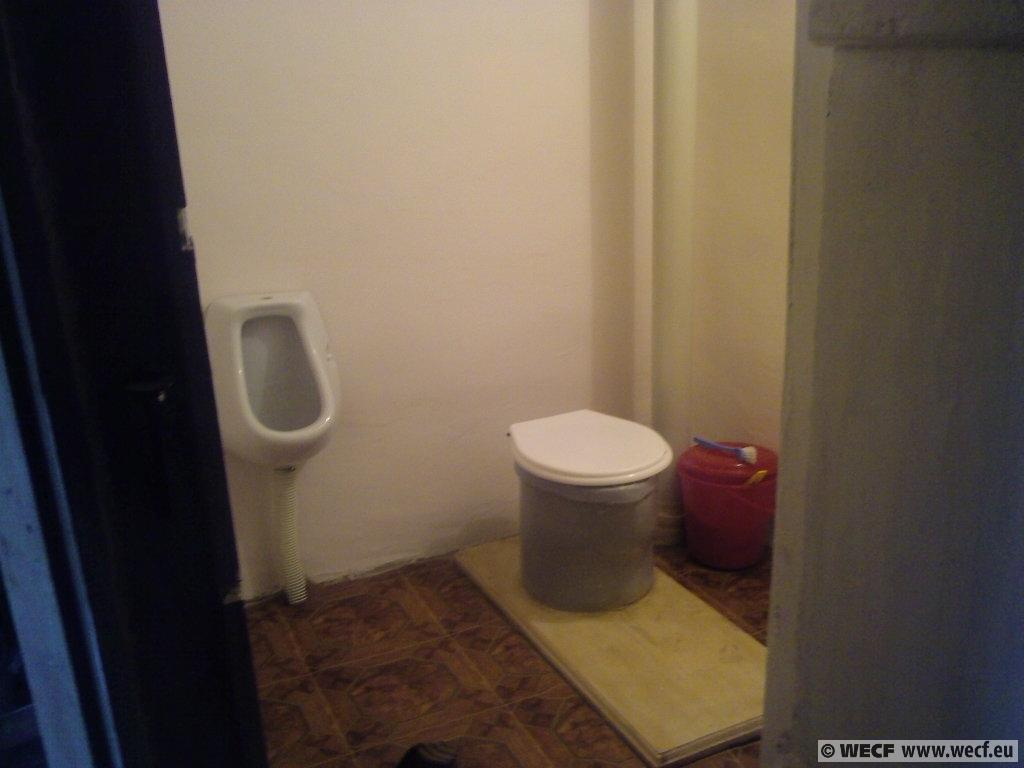What type of room is shown in the image? The image is an inside picture of a bathroom. What objects can be seen in the bathroom? There are buckets and a toilet seat visible in the image. What can be seen in the background of the image? There is a wall in the background of the image. What is at the bottom of the image? There is a floor at the bottom of the image. What type of veil is draped over the toilet seat in the image? There is no veil present in the image; the toilet seat is visible without any covering. 